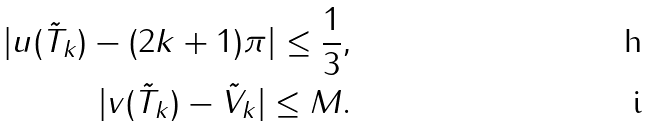Convert formula to latex. <formula><loc_0><loc_0><loc_500><loc_500>| u ( \tilde { T } _ { k } ) - ( 2 k + 1 ) \pi | \leq \frac { 1 } { 3 } , \\ | v ( \tilde { T } _ { k } ) - \tilde { V } _ { k } | \leq M .</formula> 